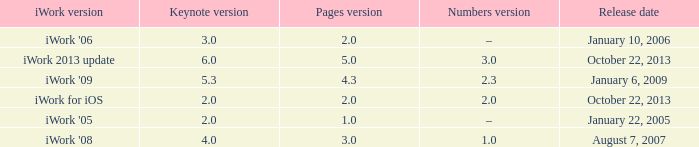What's the latest keynote version of version 2.3 of numbers with pages greater than 4.3? None. 